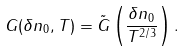<formula> <loc_0><loc_0><loc_500><loc_500>G ( \delta n _ { 0 } , T ) = \tilde { G } \left ( \frac { \delta n _ { 0 } } { T ^ { 2 / 3 } } \right ) .</formula> 